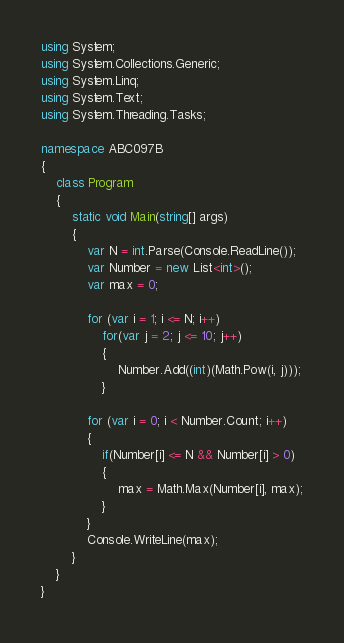Convert code to text. <code><loc_0><loc_0><loc_500><loc_500><_C#_>using System;
using System.Collections.Generic;
using System.Linq;
using System.Text;
using System.Threading.Tasks;

namespace ABC097B
{
    class Program
    {
        static void Main(string[] args)
        {
            var N = int.Parse(Console.ReadLine());
            var Number = new List<int>();
            var max = 0;

            for (var i = 1; i <= N; i++)
                for(var j = 2; j <= 10; j++)
                {
                    Number.Add((int)(Math.Pow(i, j)));
                }

            for (var i = 0; i < Number.Count; i++)
            {
                if(Number[i] <= N && Number[i] > 0)
                {
                    max = Math.Max(Number[i], max);
                }
            }
            Console.WriteLine(max);
        }
    }
}
</code> 